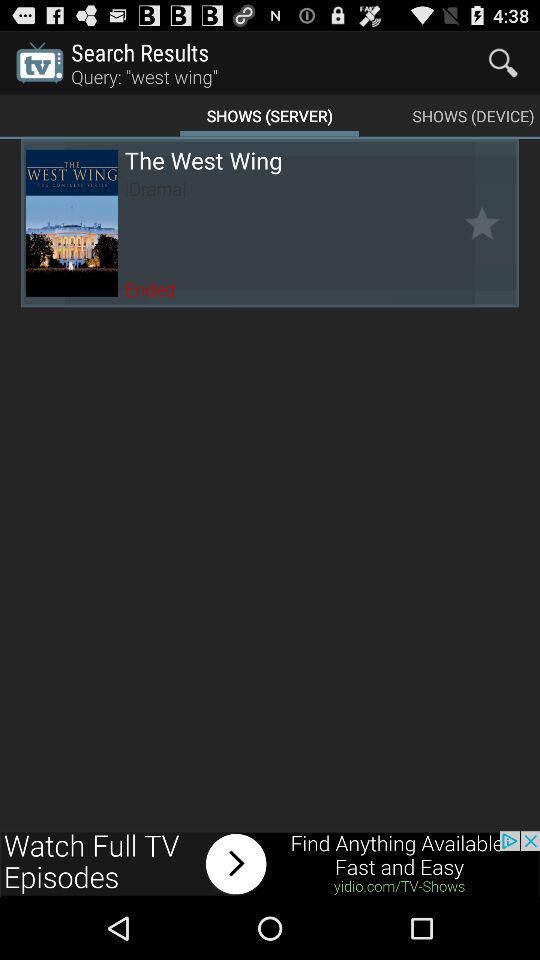What is the show's name? The show's name is "The West Wing". 